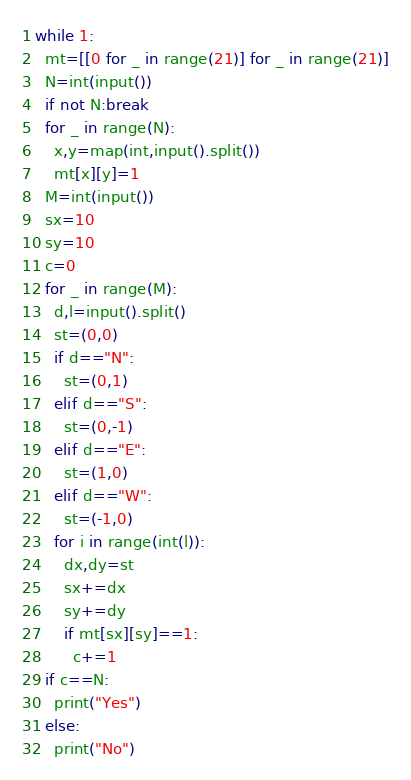Convert code to text. <code><loc_0><loc_0><loc_500><loc_500><_Python_>while 1:
  mt=[[0 for _ in range(21)] for _ in range(21)]
  N=int(input())
  if not N:break
  for _ in range(N):
    x,y=map(int,input().split())
    mt[x][y]=1
  M=int(input())
  sx=10
  sy=10
  c=0
  for _ in range(M):
    d,l=input().split()
    st=(0,0)
    if d=="N":
      st=(0,1)
    elif d=="S":
      st=(0,-1)
    elif d=="E":
      st=(1,0)
    elif d=="W":
      st=(-1,0)
    for i in range(int(l)):
      dx,dy=st
      sx+=dx
      sy+=dy
      if mt[sx][sy]==1:
        c+=1
  if c==N:
    print("Yes")
  else:
    print("No")

</code> 